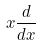Convert formula to latex. <formula><loc_0><loc_0><loc_500><loc_500>x \frac { d } { d x }</formula> 